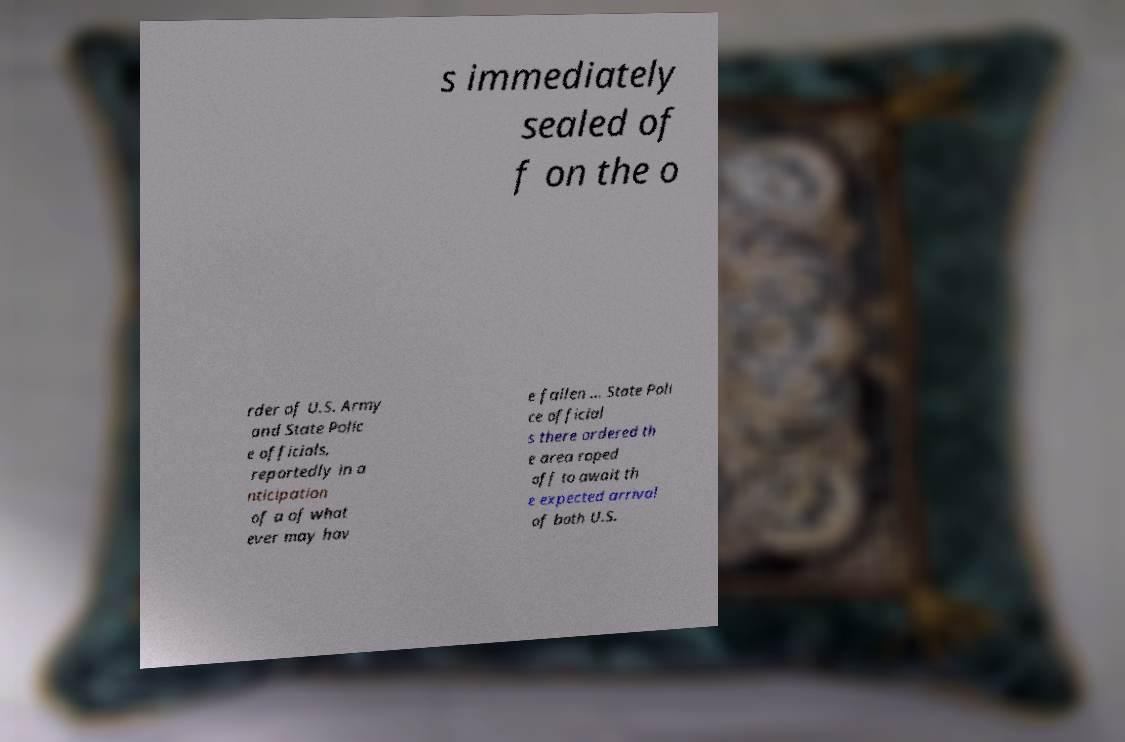Please read and relay the text visible in this image. What does it say? s immediately sealed of f on the o rder of U.S. Army and State Polic e officials, reportedly in a nticipation of a of what ever may hav e fallen ... State Poli ce official s there ordered th e area roped off to await th e expected arrival of both U.S. 